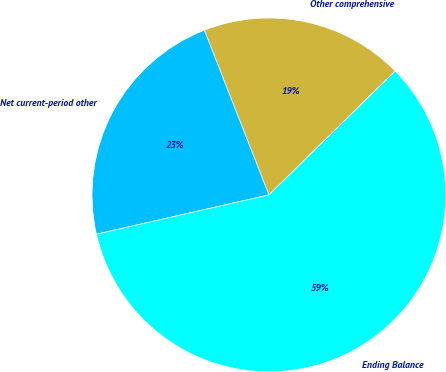Convert chart to OTSL. <chart><loc_0><loc_0><loc_500><loc_500><pie_chart><fcel>Other comprehensive<fcel>Net current-period other<fcel>Ending Balance<nl><fcel>18.6%<fcel>22.62%<fcel>58.78%<nl></chart> 